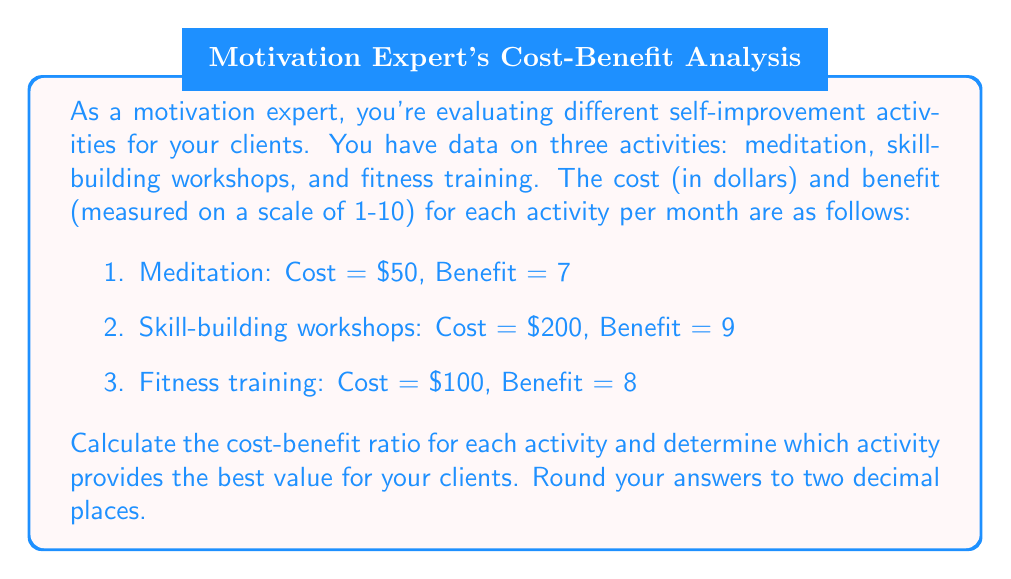Help me with this question. To solve this problem, we need to calculate the cost-benefit ratio for each activity and compare them. The cost-benefit ratio is calculated by dividing the cost by the benefit. A lower ratio indicates better value.

1. Meditation:
   Cost-benefit ratio = $\frac{\text{Cost}}{\text{Benefit}} = \frac{50}{7} \approx 7.14$

2. Skill-building workshops:
   Cost-benefit ratio = $\frac{\text{Cost}}{\text{Benefit}} = \frac{200}{9} \approx 22.22$

3. Fitness training:
   Cost-benefit ratio = $\frac{\text{Cost}}{\text{Benefit}} = \frac{100}{8} = 12.50$

Now, let's compare the ratios:

Meditation: 7.14
Skill-building workshops: 22.22
Fitness training: 12.50

The activity with the lowest cost-benefit ratio provides the best value. In this case, meditation has the lowest ratio at 7.14, making it the best value for clients.
Answer: Meditation provides the best value for clients with a cost-benefit ratio of 7.14. 